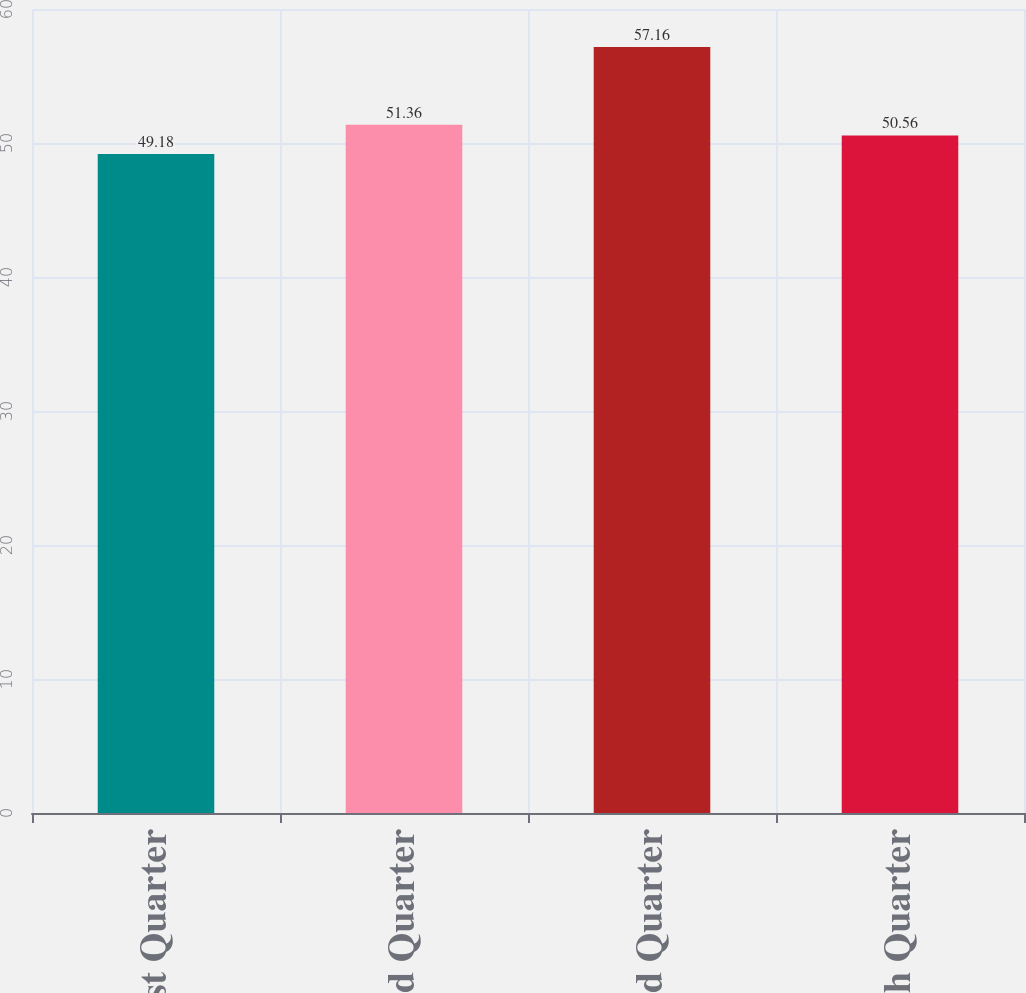<chart> <loc_0><loc_0><loc_500><loc_500><bar_chart><fcel>First Quarter<fcel>Second Quarter<fcel>Third Quarter<fcel>Fourth Quarter<nl><fcel>49.18<fcel>51.36<fcel>57.16<fcel>50.56<nl></chart> 